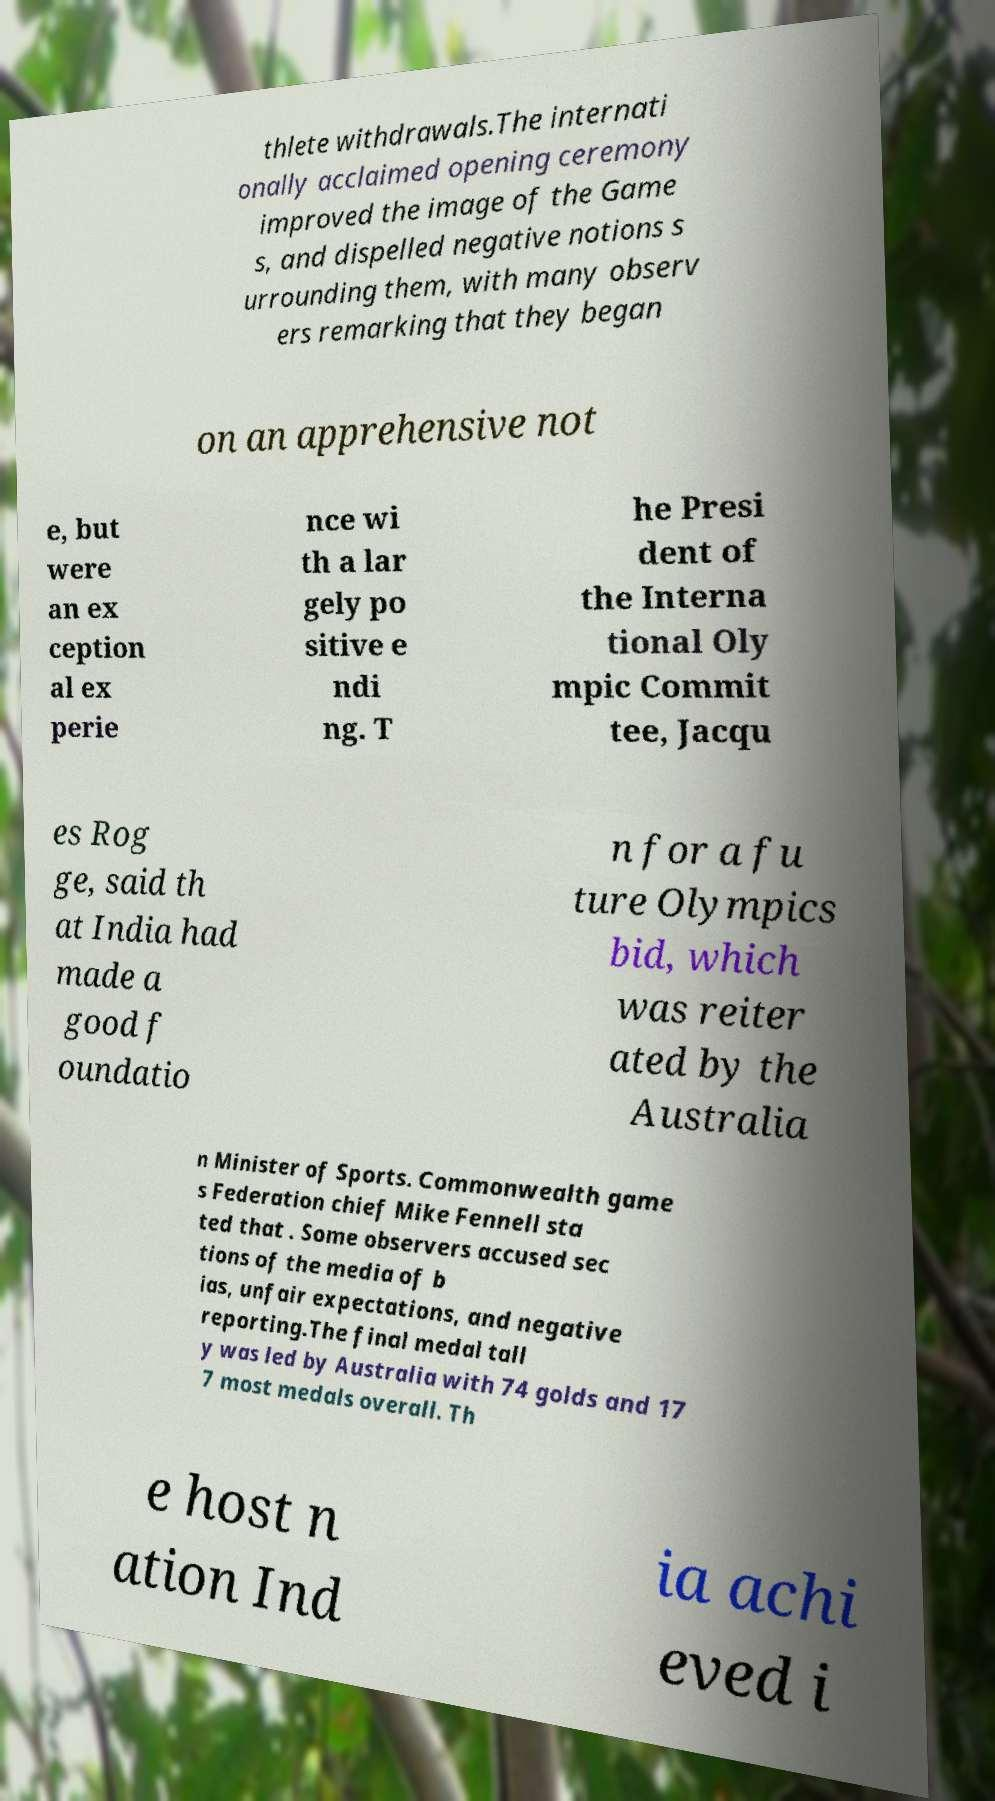Please identify and transcribe the text found in this image. thlete withdrawals.The internati onally acclaimed opening ceremony improved the image of the Game s, and dispelled negative notions s urrounding them, with many observ ers remarking that they began on an apprehensive not e, but were an ex ception al ex perie nce wi th a lar gely po sitive e ndi ng. T he Presi dent of the Interna tional Oly mpic Commit tee, Jacqu es Rog ge, said th at India had made a good f oundatio n for a fu ture Olympics bid, which was reiter ated by the Australia n Minister of Sports. Commonwealth game s Federation chief Mike Fennell sta ted that . Some observers accused sec tions of the media of b ias, unfair expectations, and negative reporting.The final medal tall y was led by Australia with 74 golds and 17 7 most medals overall. Th e host n ation Ind ia achi eved i 